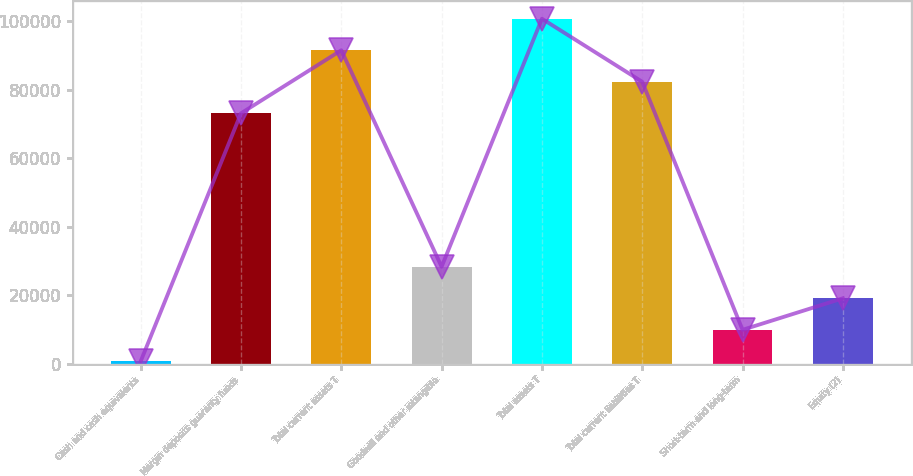<chart> <loc_0><loc_0><loc_500><loc_500><bar_chart><fcel>Cash and cash equivalents<fcel>Margin deposits guaranty funds<fcel>Total current assets T<fcel>Goodwill and other intangible<fcel>Total assets T<fcel>Total current liabilities T<fcel>Short-term and long-term<fcel>Equity (2)<nl><fcel>724<fcel>73161.7<fcel>91575.1<fcel>28344.1<fcel>100782<fcel>82368.4<fcel>9930.7<fcel>19137.4<nl></chart> 